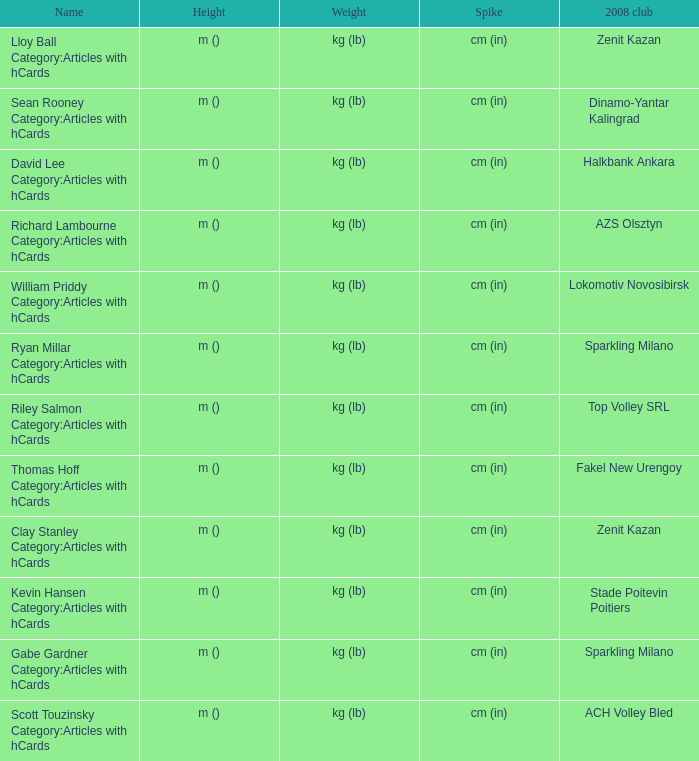What name has Fakel New Urengoy as the 2008 club? Thomas Hoff Category:Articles with hCards. 